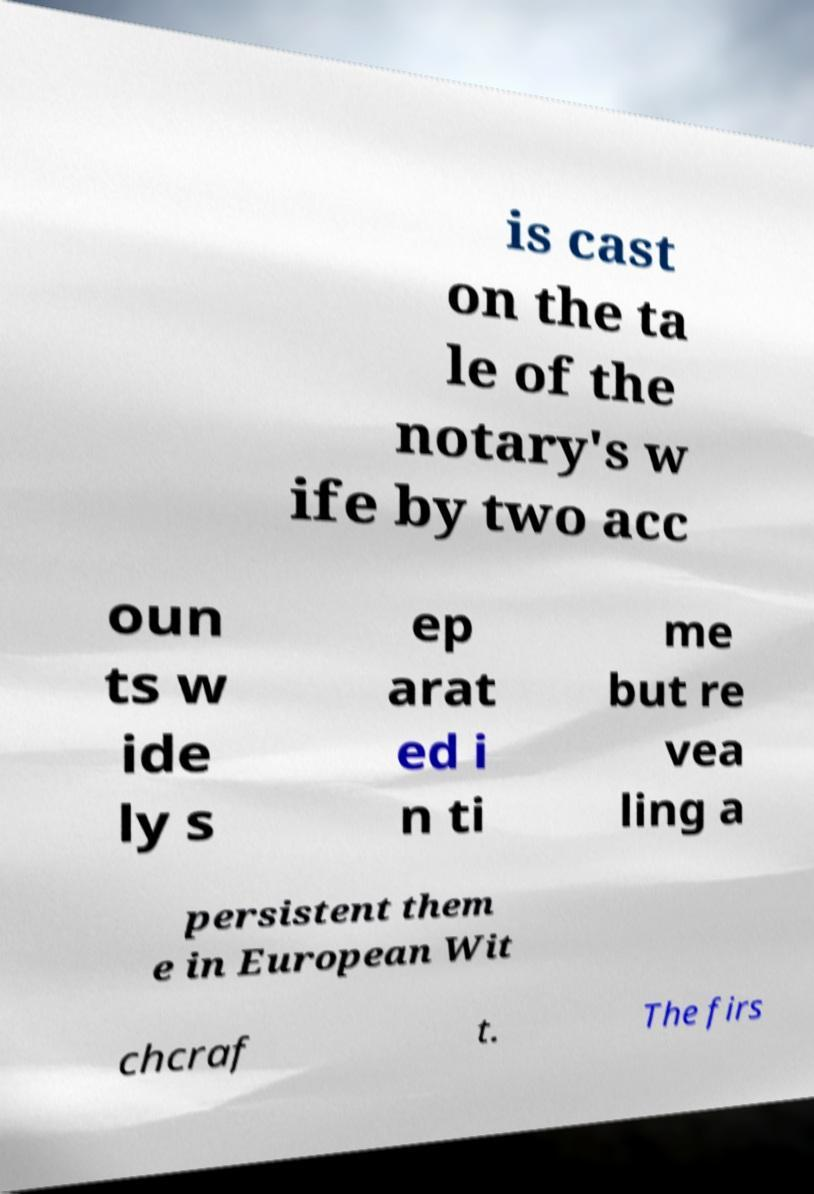Can you read and provide the text displayed in the image?This photo seems to have some interesting text. Can you extract and type it out for me? is cast on the ta le of the notary's w ife by two acc oun ts w ide ly s ep arat ed i n ti me but re vea ling a persistent them e in European Wit chcraf t. The firs 